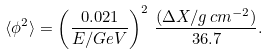<formula> <loc_0><loc_0><loc_500><loc_500>\langle \phi ^ { 2 } \rangle = \left ( \frac { 0 . 0 2 1 } { E / G e V } \right ) ^ { 2 } \, \frac { ( \Delta X / g \, c m ^ { - 2 } ) } { 3 6 . 7 } .</formula> 